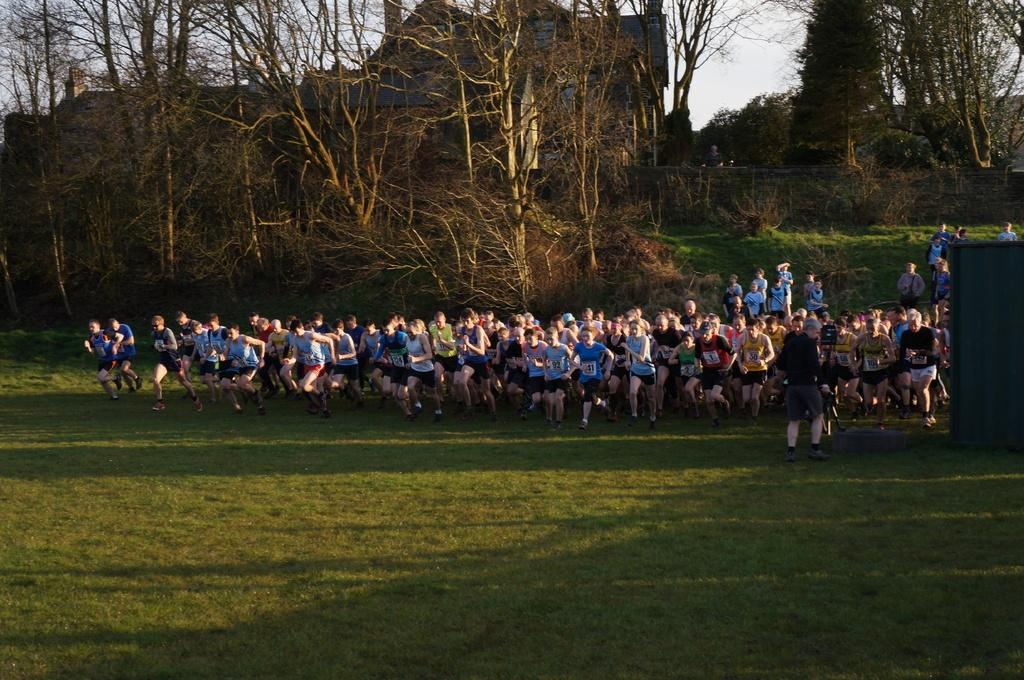What are the people in the image doing? The people in the image are running in the center of the image. What type of surface are the people running on? There is grass at the bottom of the image, which suggests that the people are running on grass. What can be seen in the background of the image? There are trees in the background of the image. What type of fan is visible in the image? There is no fan present in the image. How many thumbs can be seen on the people running in the image? It is impossible to determine the number of thumbs on the people running in the image, as only their bodies are visible, not their hands. 